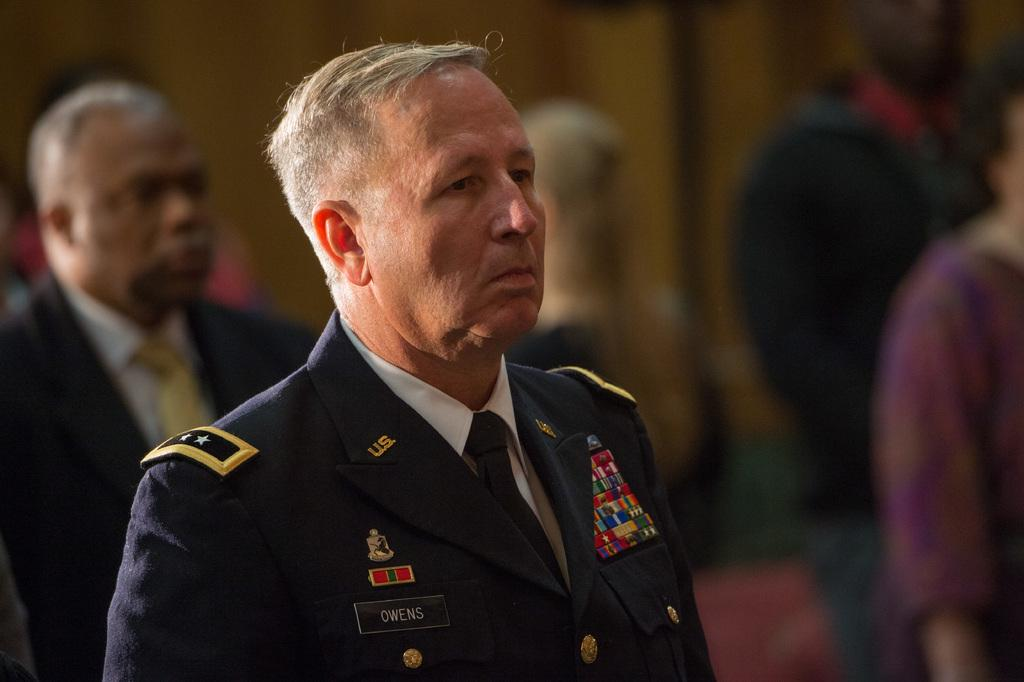What is the main subject of the image? The main subject of the image is a group of people. Can you describe the person in front of the group? The person in front is wearing a black and white dress. How is the background of the image depicted? The background of the image is blurred. What type of volcano can be seen erupting in the background of the image? There is no volcano present in the image; the background is blurred. What kind of test is being conducted by the group of people in the image? There is no indication of a test being conducted in the image; it features a group of people with a person in front wearing a black and white dress. 